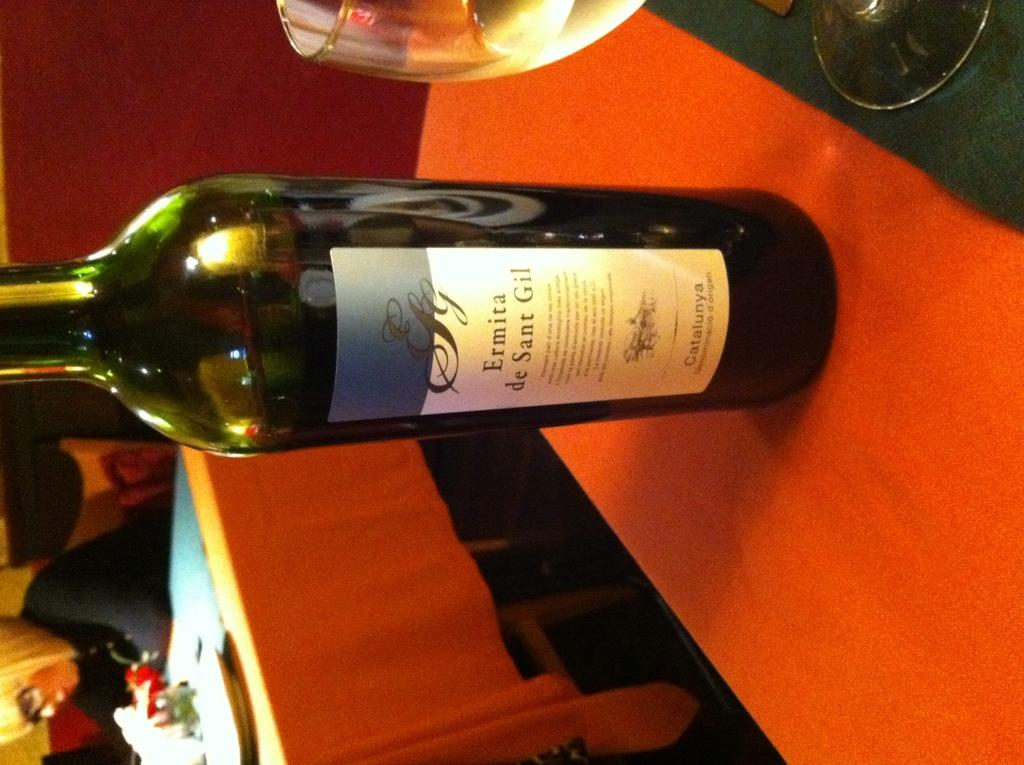<image>
Create a compact narrative representing the image presented. Bottle of  Ermita de sant gil wine in a green bottle 